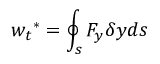<formula> <loc_0><loc_0><loc_500><loc_500>{ w _ { t } } ^ { * } = \oint _ { s } { { F _ { y } } \delta y } d s</formula> 